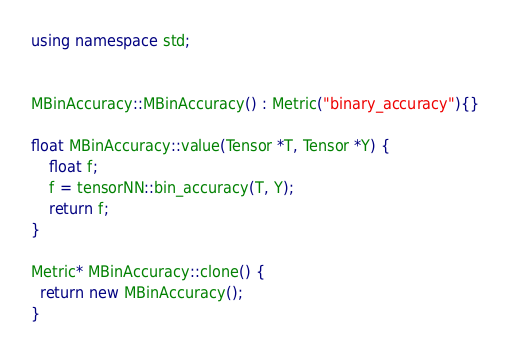<code> <loc_0><loc_0><loc_500><loc_500><_C++_>using namespace std;


MBinAccuracy::MBinAccuracy() : Metric("binary_accuracy"){}

float MBinAccuracy::value(Tensor *T, Tensor *Y) {
    float f;
    f = tensorNN::bin_accuracy(T, Y);
    return f;
}

Metric* MBinAccuracy::clone() {
  return new MBinAccuracy();
}
</code> 